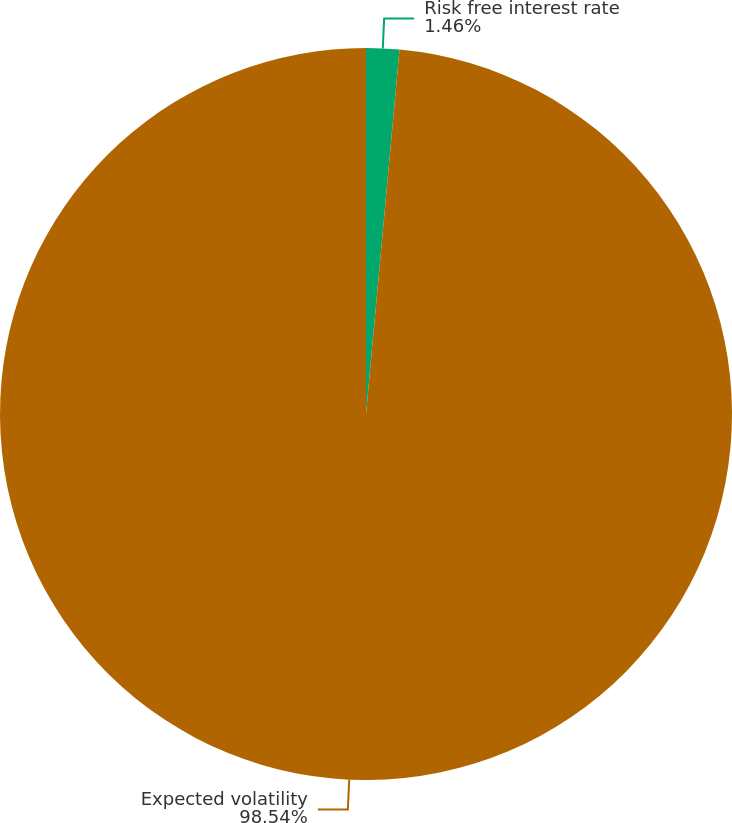Convert chart to OTSL. <chart><loc_0><loc_0><loc_500><loc_500><pie_chart><fcel>Risk free interest rate<fcel>Expected volatility<nl><fcel>1.46%<fcel>98.54%<nl></chart> 